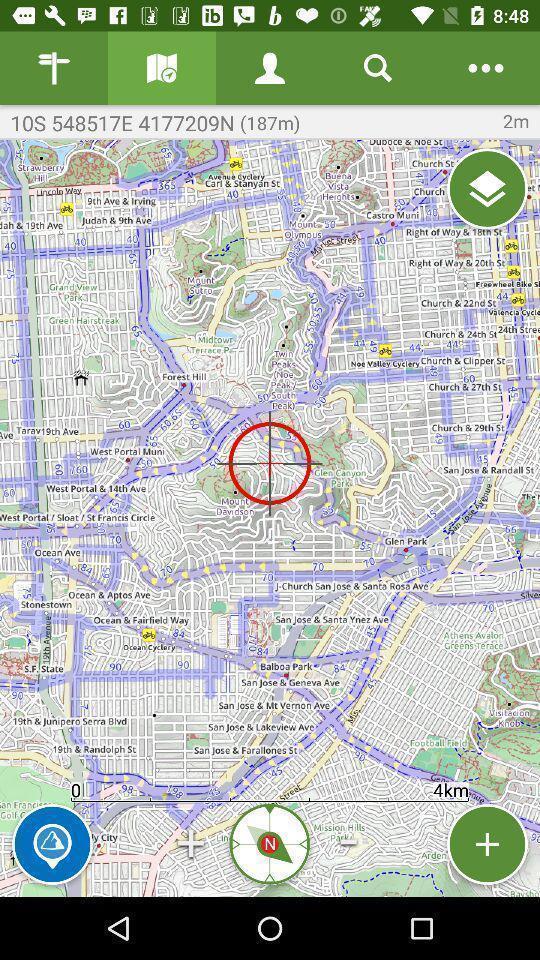Tell me about the visual elements in this screen capture. Screen displaying a map view with multiple controls. 